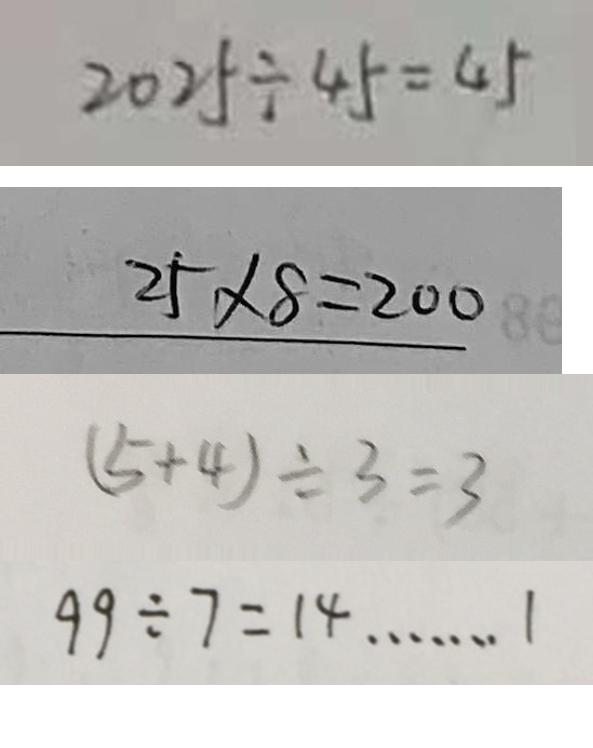Convert formula to latex. <formula><loc_0><loc_0><loc_500><loc_500>2 0 2 5 \div 4 5 = 4 5 
 2 5 \times 8 = 2 0 0 
 ( 5 + 4 ) \div 3 = 3 
 9 9 \div 7 = 1 4 \cdots 1</formula> 